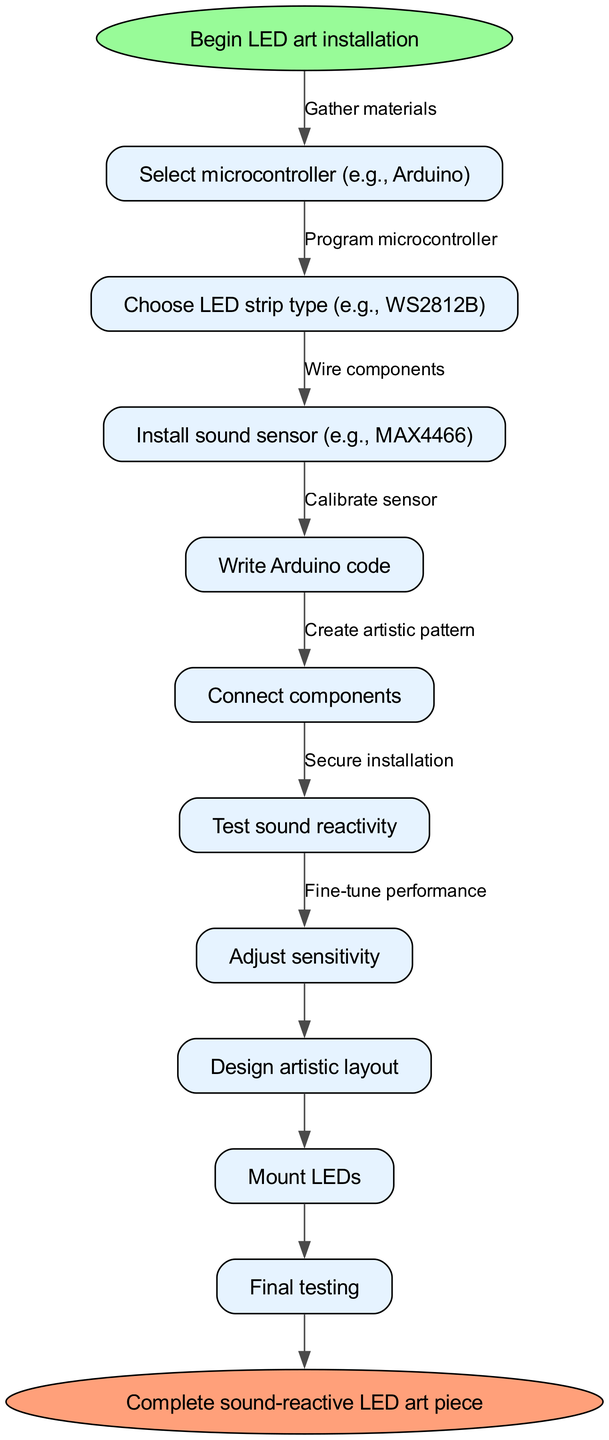What is the first step in the process? The first step, indicated in the diagram, is labeled "Begin LED art installation." This node represents the starting point of the flowchart.
Answer: Begin LED art installation How many nodes are there in total? By counting the nodes listed in the flow chart, we can see there are ten nodes including the start and end nodes.
Answer: 10 What are the materials gathered in the second step? The second step involves the node "Select microcontroller (e.g., Arduino)," which indicates choosing hardware needed for the installation. The relationship indicates this is the next action after the start.
Answer: Select microcontroller (e.g., Arduino) What is the relationship between writing Arduino code and connecting components? The diagram shows a sequence where "Write Arduino code" is followed by "Connect components." This indicates that the code is written before connecting the hardware components together.
Answer: Code before connection What does the last step in the diagram represent? The last step is labeled "Complete sound-reactive LED art piece," indicating that this is the conclusion of the process and signifies the installation is finalized after testing.
Answer: Complete sound-reactive LED art piece Which step involves adjusting the sensitivity of the sensor? The step titled "Adjust sensitivity" follows "Test sound reactivity," suggesting that the process includes fine-tuning the sensors to enhance responsiveness based on previous tests.
Answer: Adjust sensitivity What is the purpose of the 'Design artistic layout' step? "Design artistic layout" is positioned in the sequence after hardware components are connected. This shows that creating a visual design of the art is crucial and occurs after setting up the technical components.
Answer: Create visual design How is the final testing related to securing the installation? "Secure installation" occurs before "Final testing," indicating a logical order where securing the components in place must happen prior to conducting any final tests to ensure stability and functionality.
Answer: Secure before test What does the edge labeled "Gather materials" signify? The edge labeled "Gather materials" connects the start node to the first action, indicating that collecting all necessary components is crucial before beginning the installation process.
Answer: Collect all necessary components 